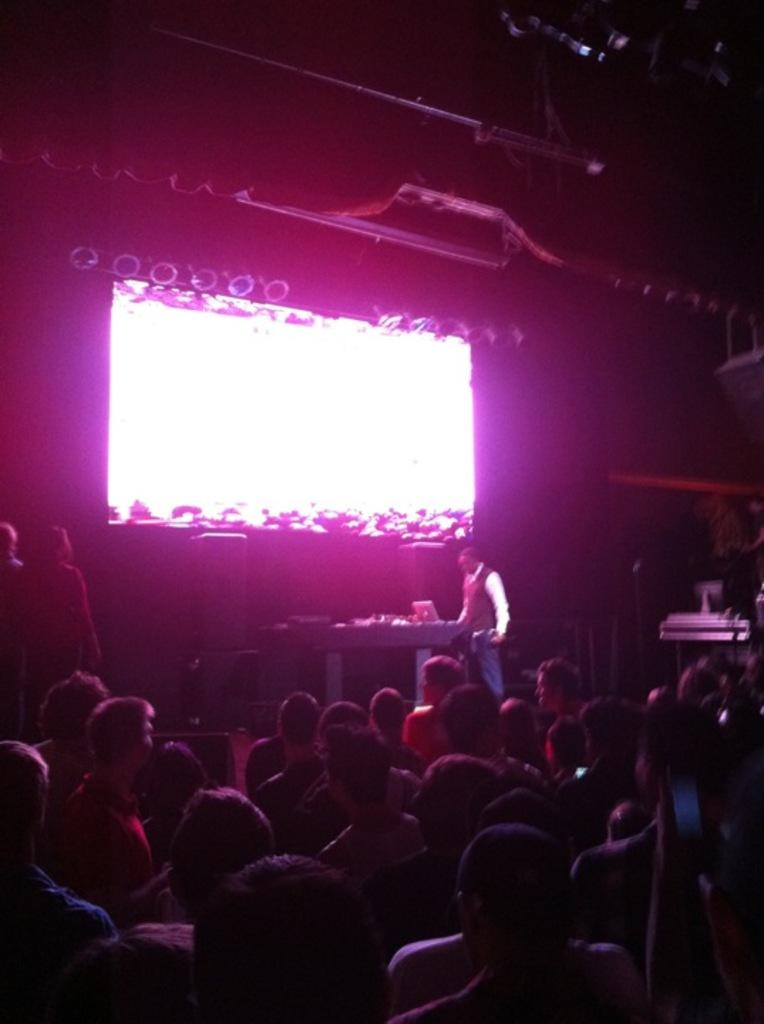How many people are visible at the bottom of the image? There are many people sitting at the bottom of the image. What is located in front of the people? There is a stage in front of the people. What is on the stage? There is a table on the stage. Who is on the stage? A man is standing on the stage. What is behind the man on the stage? There is a screen behind the man on the stage. What can be seen on the screen? Lights are visible on the screen. Can you tell me how many times the expert's tongue is visible in the image? There is no expert or tongue present in the image. Is there a church visible in the image? There is no church present in the image. 